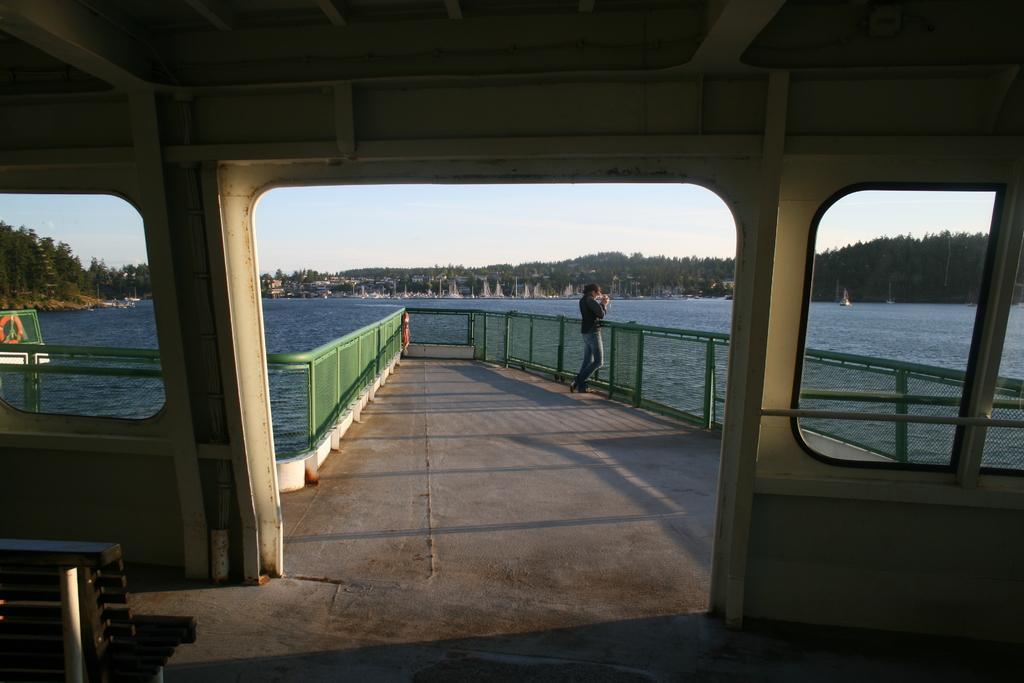Please provide a concise description of this image. This image is taken from a room having a bench. Behind the wall there is fence. A person is standing before a fence. There is water. Behind there are few trees on the land. Top of it there is sky. 